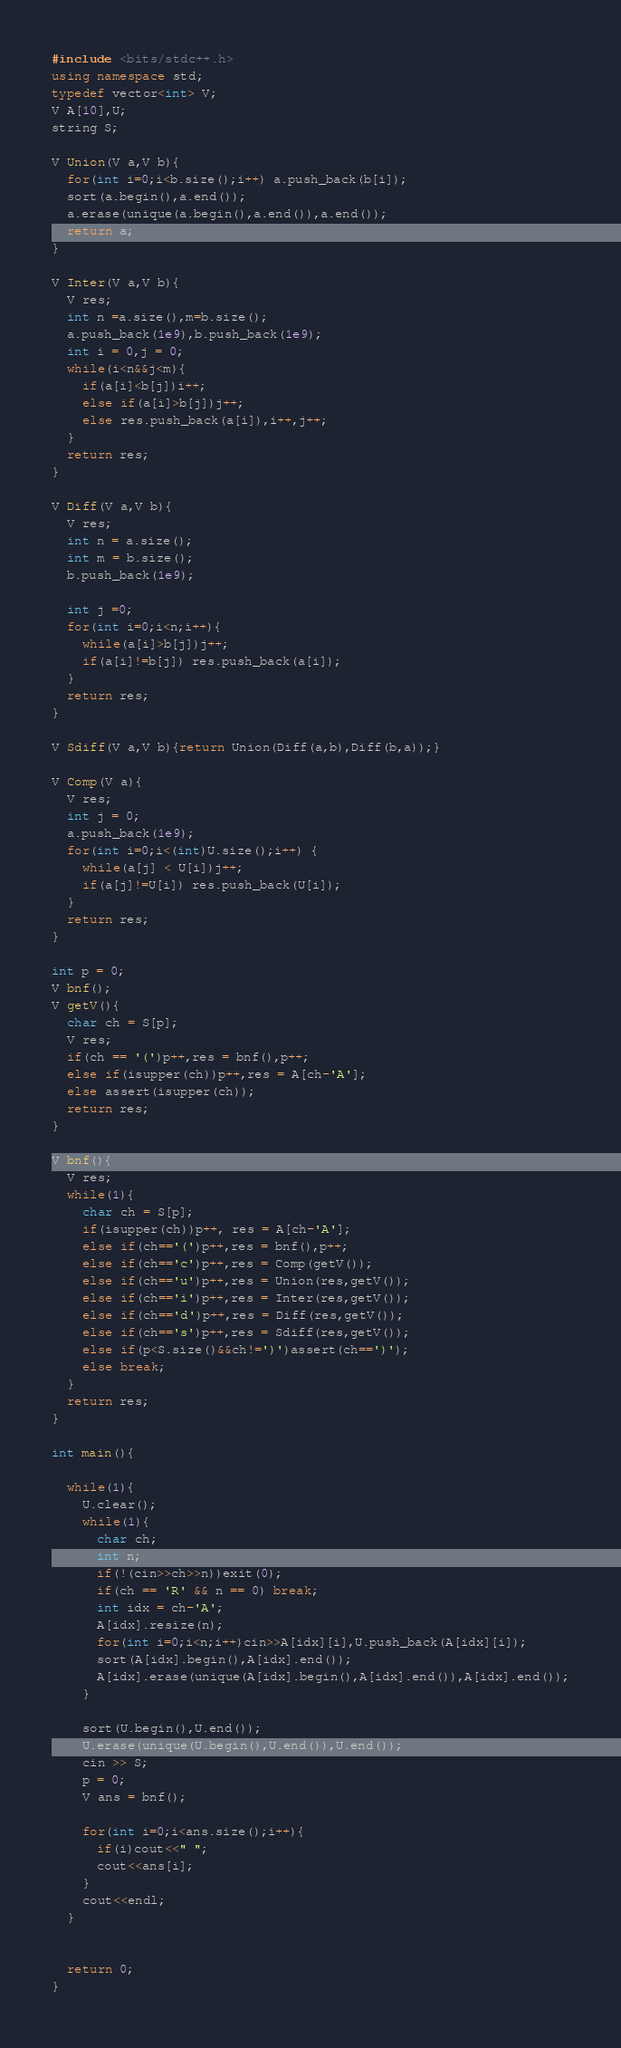Convert code to text. <code><loc_0><loc_0><loc_500><loc_500><_C++_>#include <bits/stdc++.h>
using namespace std;
typedef vector<int> V;
V A[10],U;
string S;

V Union(V a,V b){
  for(int i=0;i<b.size();i++) a.push_back(b[i]);
  sort(a.begin(),a.end());
  a.erase(unique(a.begin(),a.end()),a.end());
  return a;
}

V Inter(V a,V b){
  V res;
  int n =a.size(),m=b.size();
  a.push_back(1e9),b.push_back(1e9);
  int i = 0,j = 0;
  while(i<n&&j<m){
    if(a[i]<b[j])i++;
    else if(a[i]>b[j])j++;
    else res.push_back(a[i]),i++,j++;
  }
  return res;
}

V Diff(V a,V b){
  V res;
  int n = a.size();
  int m = b.size();
  b.push_back(1e9);
  
  int j =0;
  for(int i=0;i<n;i++){
    while(a[i]>b[j])j++;
    if(a[i]!=b[j]) res.push_back(a[i]);
  }
  return res;
}

V Sdiff(V a,V b){return Union(Diff(a,b),Diff(b,a));}

V Comp(V a){
  V res;
  int j = 0;
  a.push_back(1e9);
  for(int i=0;i<(int)U.size();i++) {
    while(a[j] < U[i])j++;
    if(a[j]!=U[i]) res.push_back(U[i]);
  }
  return res;
}

int p = 0;
V bnf();
V getV(){
  char ch = S[p];
  V res;
  if(ch == '(')p++,res = bnf(),p++;
  else if(isupper(ch))p++,res = A[ch-'A'];
  else assert(isupper(ch));
  return res;
}

V bnf(){
  V res;
  while(1){
    char ch = S[p];
    if(isupper(ch))p++, res = A[ch-'A'];
    else if(ch=='(')p++,res = bnf(),p++;
    else if(ch=='c')p++,res = Comp(getV());
    else if(ch=='u')p++,res = Union(res,getV());
    else if(ch=='i')p++,res = Inter(res,getV());
    else if(ch=='d')p++,res = Diff(res,getV());
    else if(ch=='s')p++,res = Sdiff(res,getV());
    else if(p<S.size()&&ch!=')')assert(ch==')');
    else break;
  }
  return res;
}

int main(){

  while(1){
    U.clear();
    while(1){
      char ch;
      int n;
      if(!(cin>>ch>>n))exit(0);
      if(ch == 'R' && n == 0) break;
      int idx = ch-'A';
      A[idx].resize(n);
      for(int i=0;i<n;i++)cin>>A[idx][i],U.push_back(A[idx][i]);
      sort(A[idx].begin(),A[idx].end());
      A[idx].erase(unique(A[idx].begin(),A[idx].end()),A[idx].end());
    }
    
    sort(U.begin(),U.end());
    U.erase(unique(U.begin(),U.end()),U.end());
    cin >> S;
    p = 0;
    V ans = bnf();

    for(int i=0;i<ans.size();i++){
      if(i)cout<<" ";
      cout<<ans[i];
    }
    cout<<endl;
  }
 

  return 0;
}</code> 